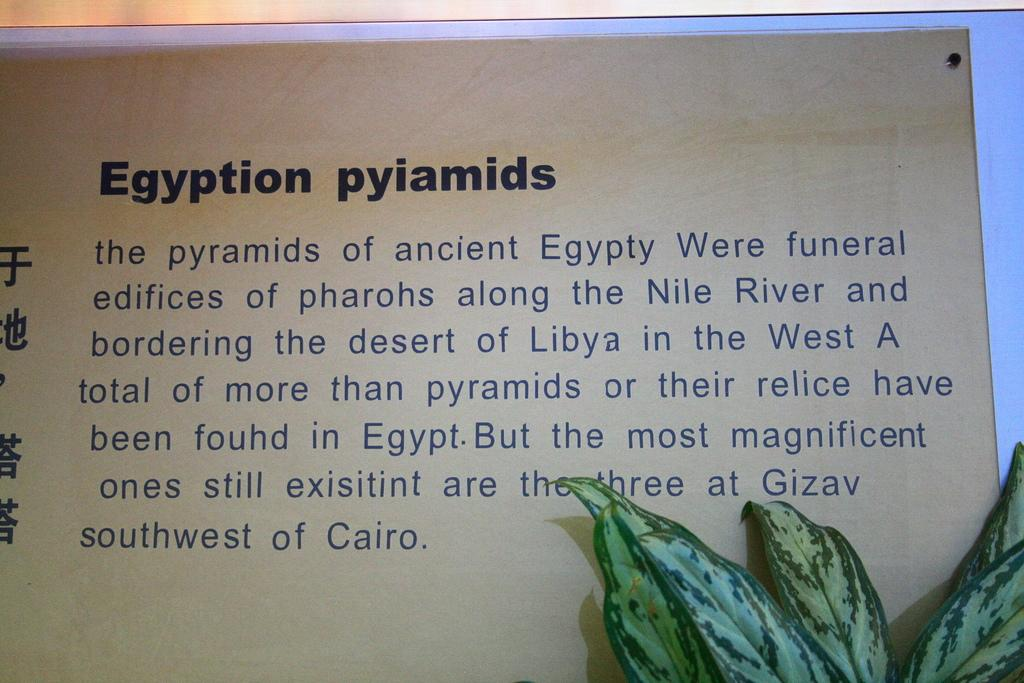<image>
Summarize the visual content of the image. A book open to a page describing the Egyptian pyramids. 